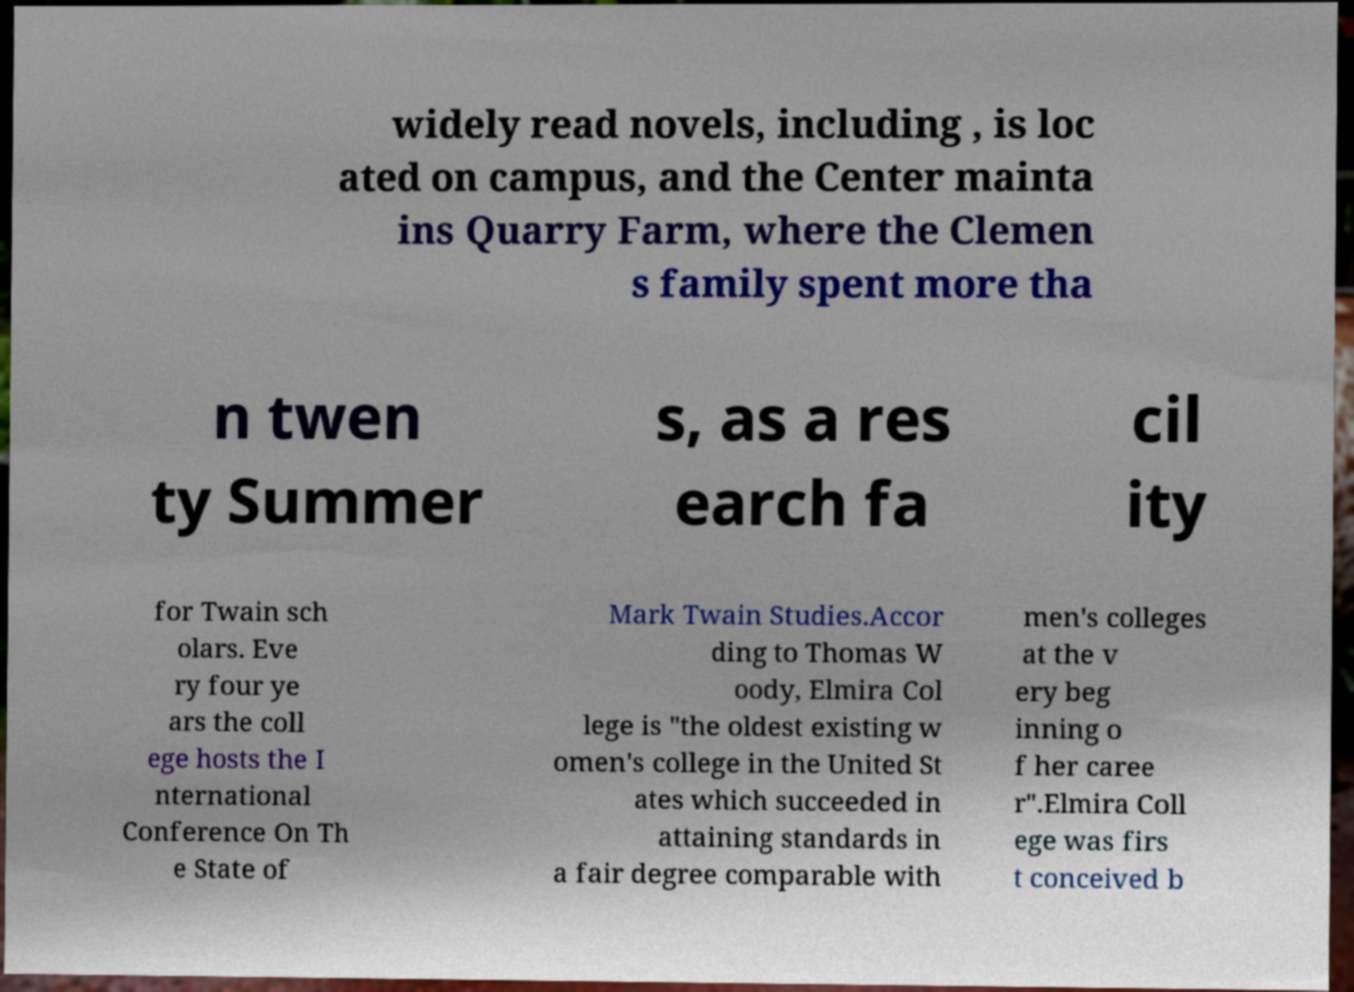What messages or text are displayed in this image? I need them in a readable, typed format. widely read novels, including , is loc ated on campus, and the Center mainta ins Quarry Farm, where the Clemen s family spent more tha n twen ty Summer s, as a res earch fa cil ity for Twain sch olars. Eve ry four ye ars the coll ege hosts the I nternational Conference On Th e State of Mark Twain Studies.Accor ding to Thomas W oody, Elmira Col lege is "the oldest existing w omen's college in the United St ates which succeeded in attaining standards in a fair degree comparable with men's colleges at the v ery beg inning o f her caree r".Elmira Coll ege was firs t conceived b 